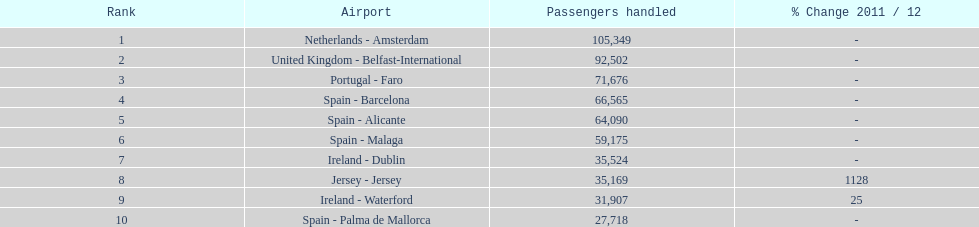How many airports are listed? 10. 